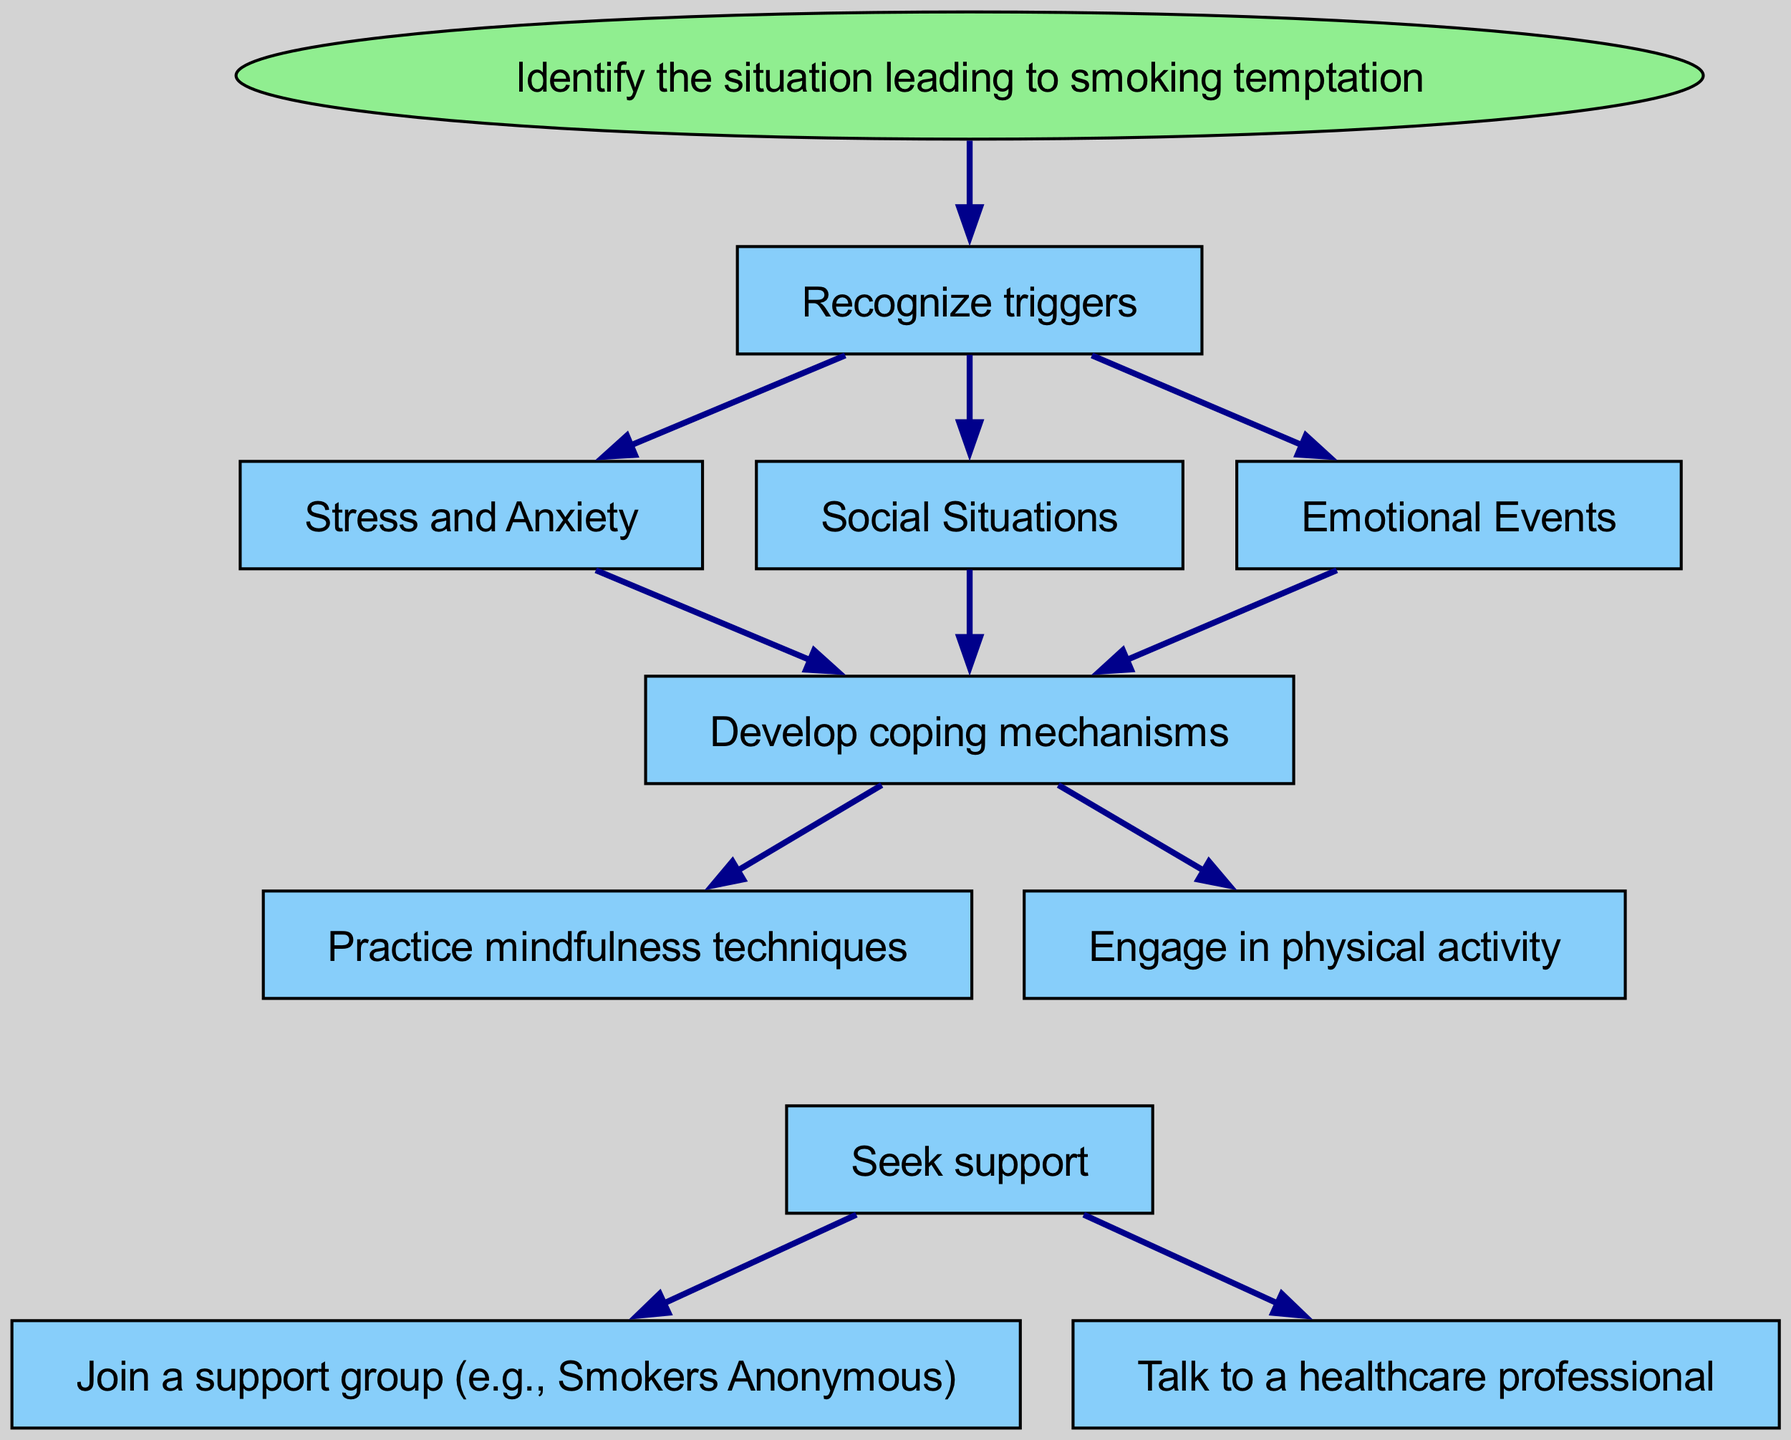What is the starting point of the flow chart? The flow chart begins with the node titled "Identify the situation leading to smoking temptation". This is where the process starts, guiding the user to recognize the contexts that may trigger the urge to smoke.
Answer: Identify the situation leading to smoking temptation How many main steps are there after recognizing triggers? After recognizing triggers, there are three specific situations (Stress and Anxiety, Social Situations, Emotional Events) that lead to developing coping mechanisms. Therefore, there are three main steps here.
Answer: 3 What should one do after identifying a trigger? After identifying a trigger, the next step is to "Develop coping mechanisms". This indicates what needs to be done to handle the urge to smoke after recognizing a triggering situation.
Answer: Develop coping mechanisms Which two actions follow the development of coping mechanisms? After developing coping mechanisms, one can either "Practice mindfulness techniques" or "Engage in physical activity". This emphasizes the different strategies that can be employed to cope with the triggers.
Answer: Practice mindfulness techniques or Engage in physical activity What nodes do the coping mechanisms lead to? The coping mechanisms lead to the node "Seek support". It connects the coping strategies to seeking help from others, highlighting the importance of support in relapse prevention.
Answer: Seek support What are the specific support options listed in the diagram? The options available for support are "Join a support group (e.g., Smokers Anonymous)" and "Talk to a healthcare professional". These are specific pathways for seeking support in the journey to remain smoke-free.
Answer: Join a support group (e.g., Smokers Anonymous) or Talk to a healthcare professional What type of diagram is being represented and why is it significant? This is a flow chart, which is significant because it visually maps out a structured approach for preventing smoking relapse by delineating the steps, triggers, coping mechanisms, and sources of support.
Answer: Flow chart What action leads off from the "Seek support" node? The "Seek support" node leads to two actions: joining a support group or talking to a healthcare professional. This indicates the resources available for additional support in the quitting process.
Answer: Join a support group or Talk to a healthcare professional 